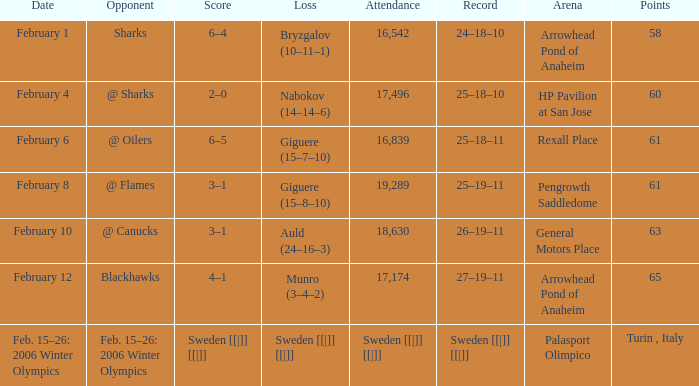Can you provide the record when the score reached 2-0? 25–18–10. I'm looking to parse the entire table for insights. Could you assist me with that? {'header': ['Date', 'Opponent', 'Score', 'Loss', 'Attendance', 'Record', 'Arena', 'Points'], 'rows': [['February 1', 'Sharks', '6–4', 'Bryzgalov (10–11–1)', '16,542', '24–18–10', 'Arrowhead Pond of Anaheim', '58'], ['February 4', '@ Sharks', '2–0', 'Nabokov (14–14–6)', '17,496', '25–18–10', 'HP Pavilion at San Jose', '60'], ['February 6', '@ Oilers', '6–5', 'Giguere (15–7–10)', '16,839', '25–18–11', 'Rexall Place', '61'], ['February 8', '@ Flames', '3–1', 'Giguere (15–8–10)', '19,289', '25–19–11', 'Pengrowth Saddledome', '61'], ['February 10', '@ Canucks', '3–1', 'Auld (24–16–3)', '18,630', '26–19–11', 'General Motors Place', '63'], ['February 12', 'Blackhawks', '4–1', 'Munro (3–4–2)', '17,174', '27–19–11', 'Arrowhead Pond of Anaheim', '65'], ['Feb. 15–26: 2006 Winter Olympics', 'Feb. 15–26: 2006 Winter Olympics', 'Sweden [[|]] [[|]]', 'Sweden [[|]] [[|]]', 'Sweden [[|]] [[|]]', 'Sweden [[|]] [[|]]', 'Palasport Olimpico', 'Turin , Italy']]} 